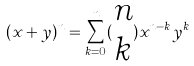<formula> <loc_0><loc_0><loc_500><loc_500>( x + y ) ^ { n } = \sum _ { k = 0 } ^ { n } ( \begin{matrix} n \\ k \end{matrix} ) x ^ { n - k } y ^ { k }</formula> 